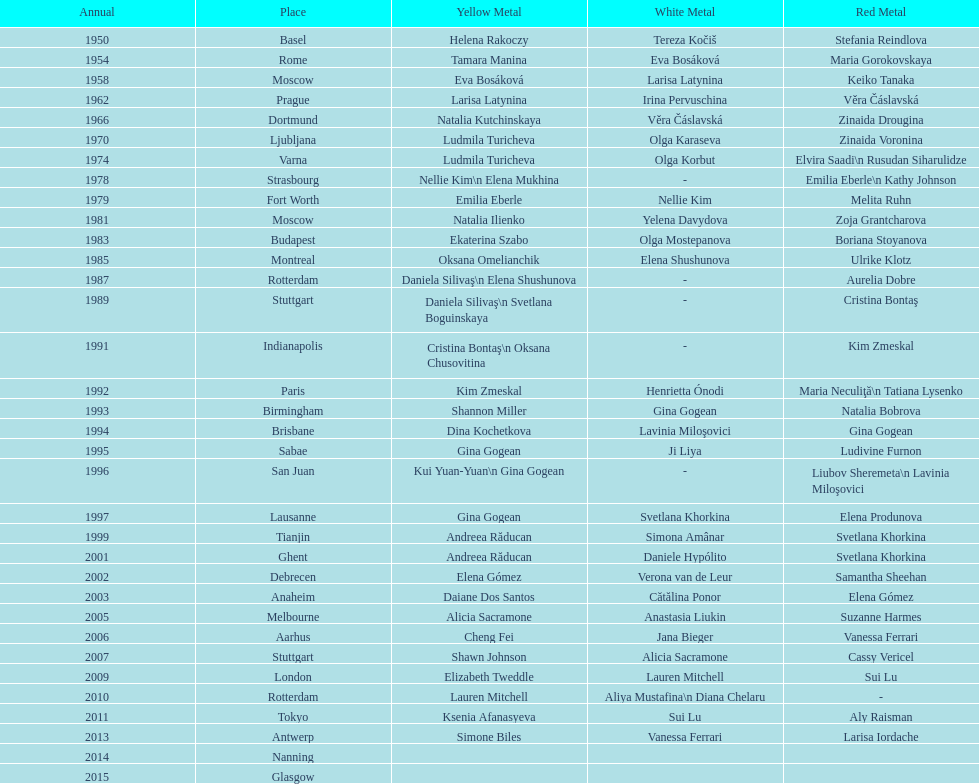Which two american rivals won consecutive floor exercise gold medals at the artistic gymnastics world championships in 1992 and 1993? Kim Zmeskal, Shannon Miller. 